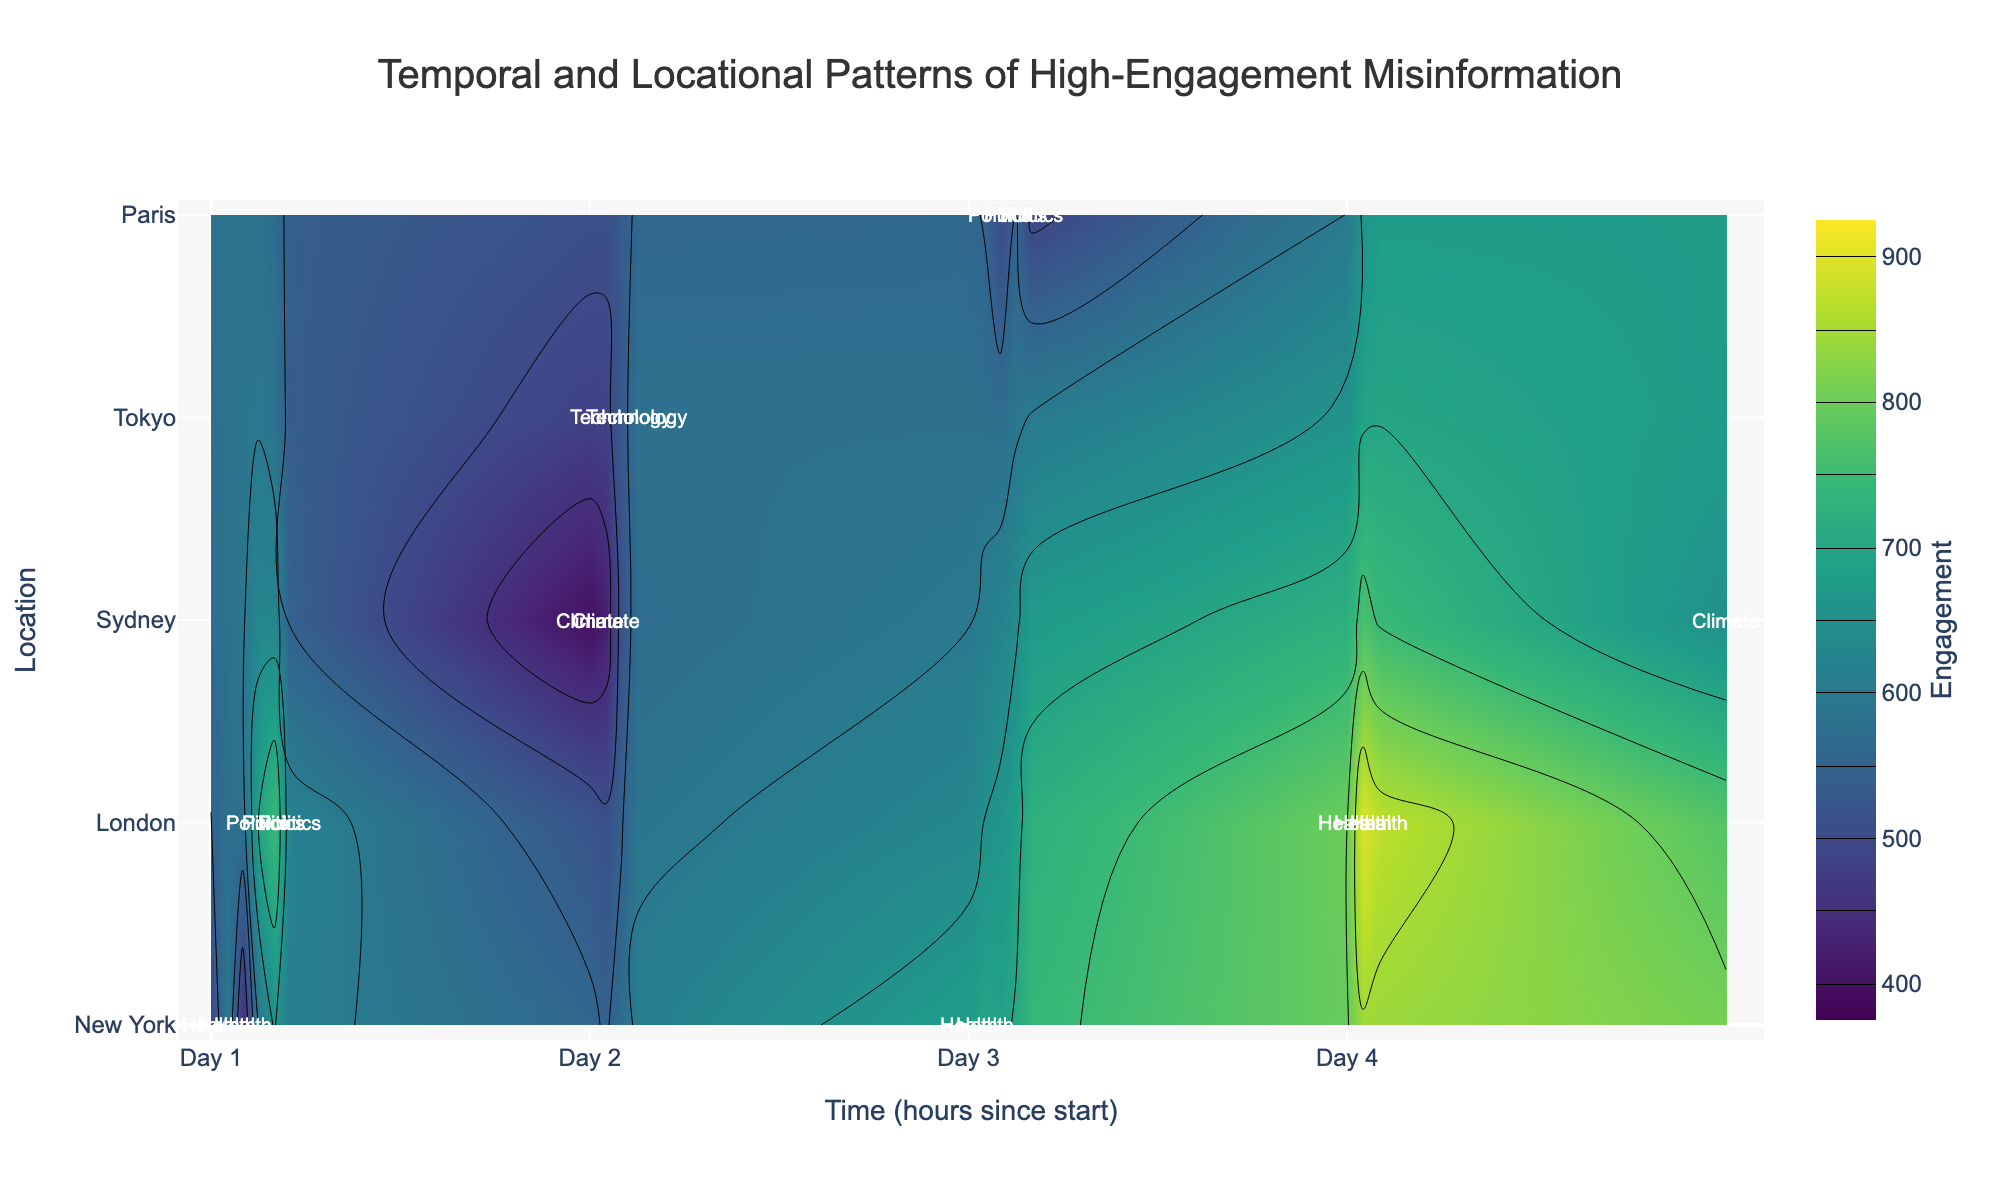How many different locations are displayed in the plot? There are unique labels/annotations visible along the "Location" axis. Each unique label corresponds to a different location. By counting the labels, you can find how many different locations are shown.
Answer: 5 What is the range of engagement values visualized in the plot? The contour plot's color scale indicates the engagement values. The legend on the right side of the plot specifies the start value as 400 and the end value as 900.
Answer: 400 to 900 Which location exhibits the highest engagement on October 4th? By examining the annotations and the highest contour colors on October 4th in the plot, you can see which location has the highest engagement based on the contour density and color intensity.
Answer: London What pattern of misinformation type had the highest engagement in Sydney? Identify the annotations labeled with the misinformation type in the Sydney location, and then check the engagement levels associated with those annotations.
Answer: Climate Change Denial Compare the engagement of Health misinformation content in New York on October 1st and October 3rd. Which day had higher engagement? Locate the Health misinformation annotations in New York for both dates, then compare the engagement values indicated by the color intensity of the contours.
Answer: October 3rd Which day experienced the peak engagement in London for Politics misinformation? Identify the Politics misinformation annotations in London and look for the maximum engagement value by checking the contour colors and any peaks around annotations.
Answer: October 1st What is the time range during which Health misinformation peaks in London? Observe the Health misinformation annotations in London and identify the hours where the highest engagement values are represented by the densest and darkest contour colors.
Answer: 8:00 - 10:00 on October 4th Are there any locations where the engagement for Technology misinformation surpasses that for Politics misinformation? Compare the contour intensities and colors for Technology and Politics misinformation annotations in different locations to determine if Technology misinformation has higher engagement in any location.
Answer: No What's the overall trend for the engagement of COVID-19 Vaccine Hoax in New York over the observed periods? Track the annotations and contour values for COVID-19 Vaccine Hoax in New York across the different dates and times to observe whether engagement increases, decreases, or remains steady over time.
Answer: Increasing 